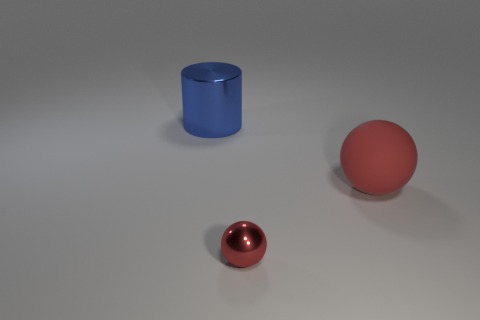Add 3 blue cylinders. How many objects exist? 6 Subtract all cylinders. How many objects are left? 2 Subtract all tiny red metal objects. Subtract all big cyan spheres. How many objects are left? 2 Add 2 small shiny balls. How many small shiny balls are left? 3 Add 1 shiny cylinders. How many shiny cylinders exist? 2 Subtract 0 brown cylinders. How many objects are left? 3 